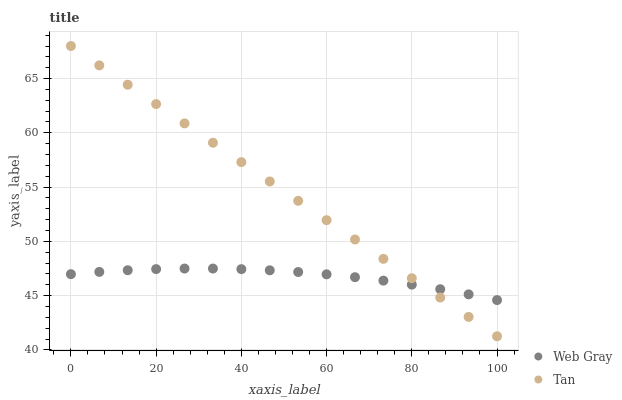Does Web Gray have the minimum area under the curve?
Answer yes or no. Yes. Does Tan have the maximum area under the curve?
Answer yes or no. Yes. Does Web Gray have the maximum area under the curve?
Answer yes or no. No. Is Tan the smoothest?
Answer yes or no. Yes. Is Web Gray the roughest?
Answer yes or no. Yes. Is Web Gray the smoothest?
Answer yes or no. No. Does Tan have the lowest value?
Answer yes or no. Yes. Does Web Gray have the lowest value?
Answer yes or no. No. Does Tan have the highest value?
Answer yes or no. Yes. Does Web Gray have the highest value?
Answer yes or no. No. Does Tan intersect Web Gray?
Answer yes or no. Yes. Is Tan less than Web Gray?
Answer yes or no. No. Is Tan greater than Web Gray?
Answer yes or no. No. 